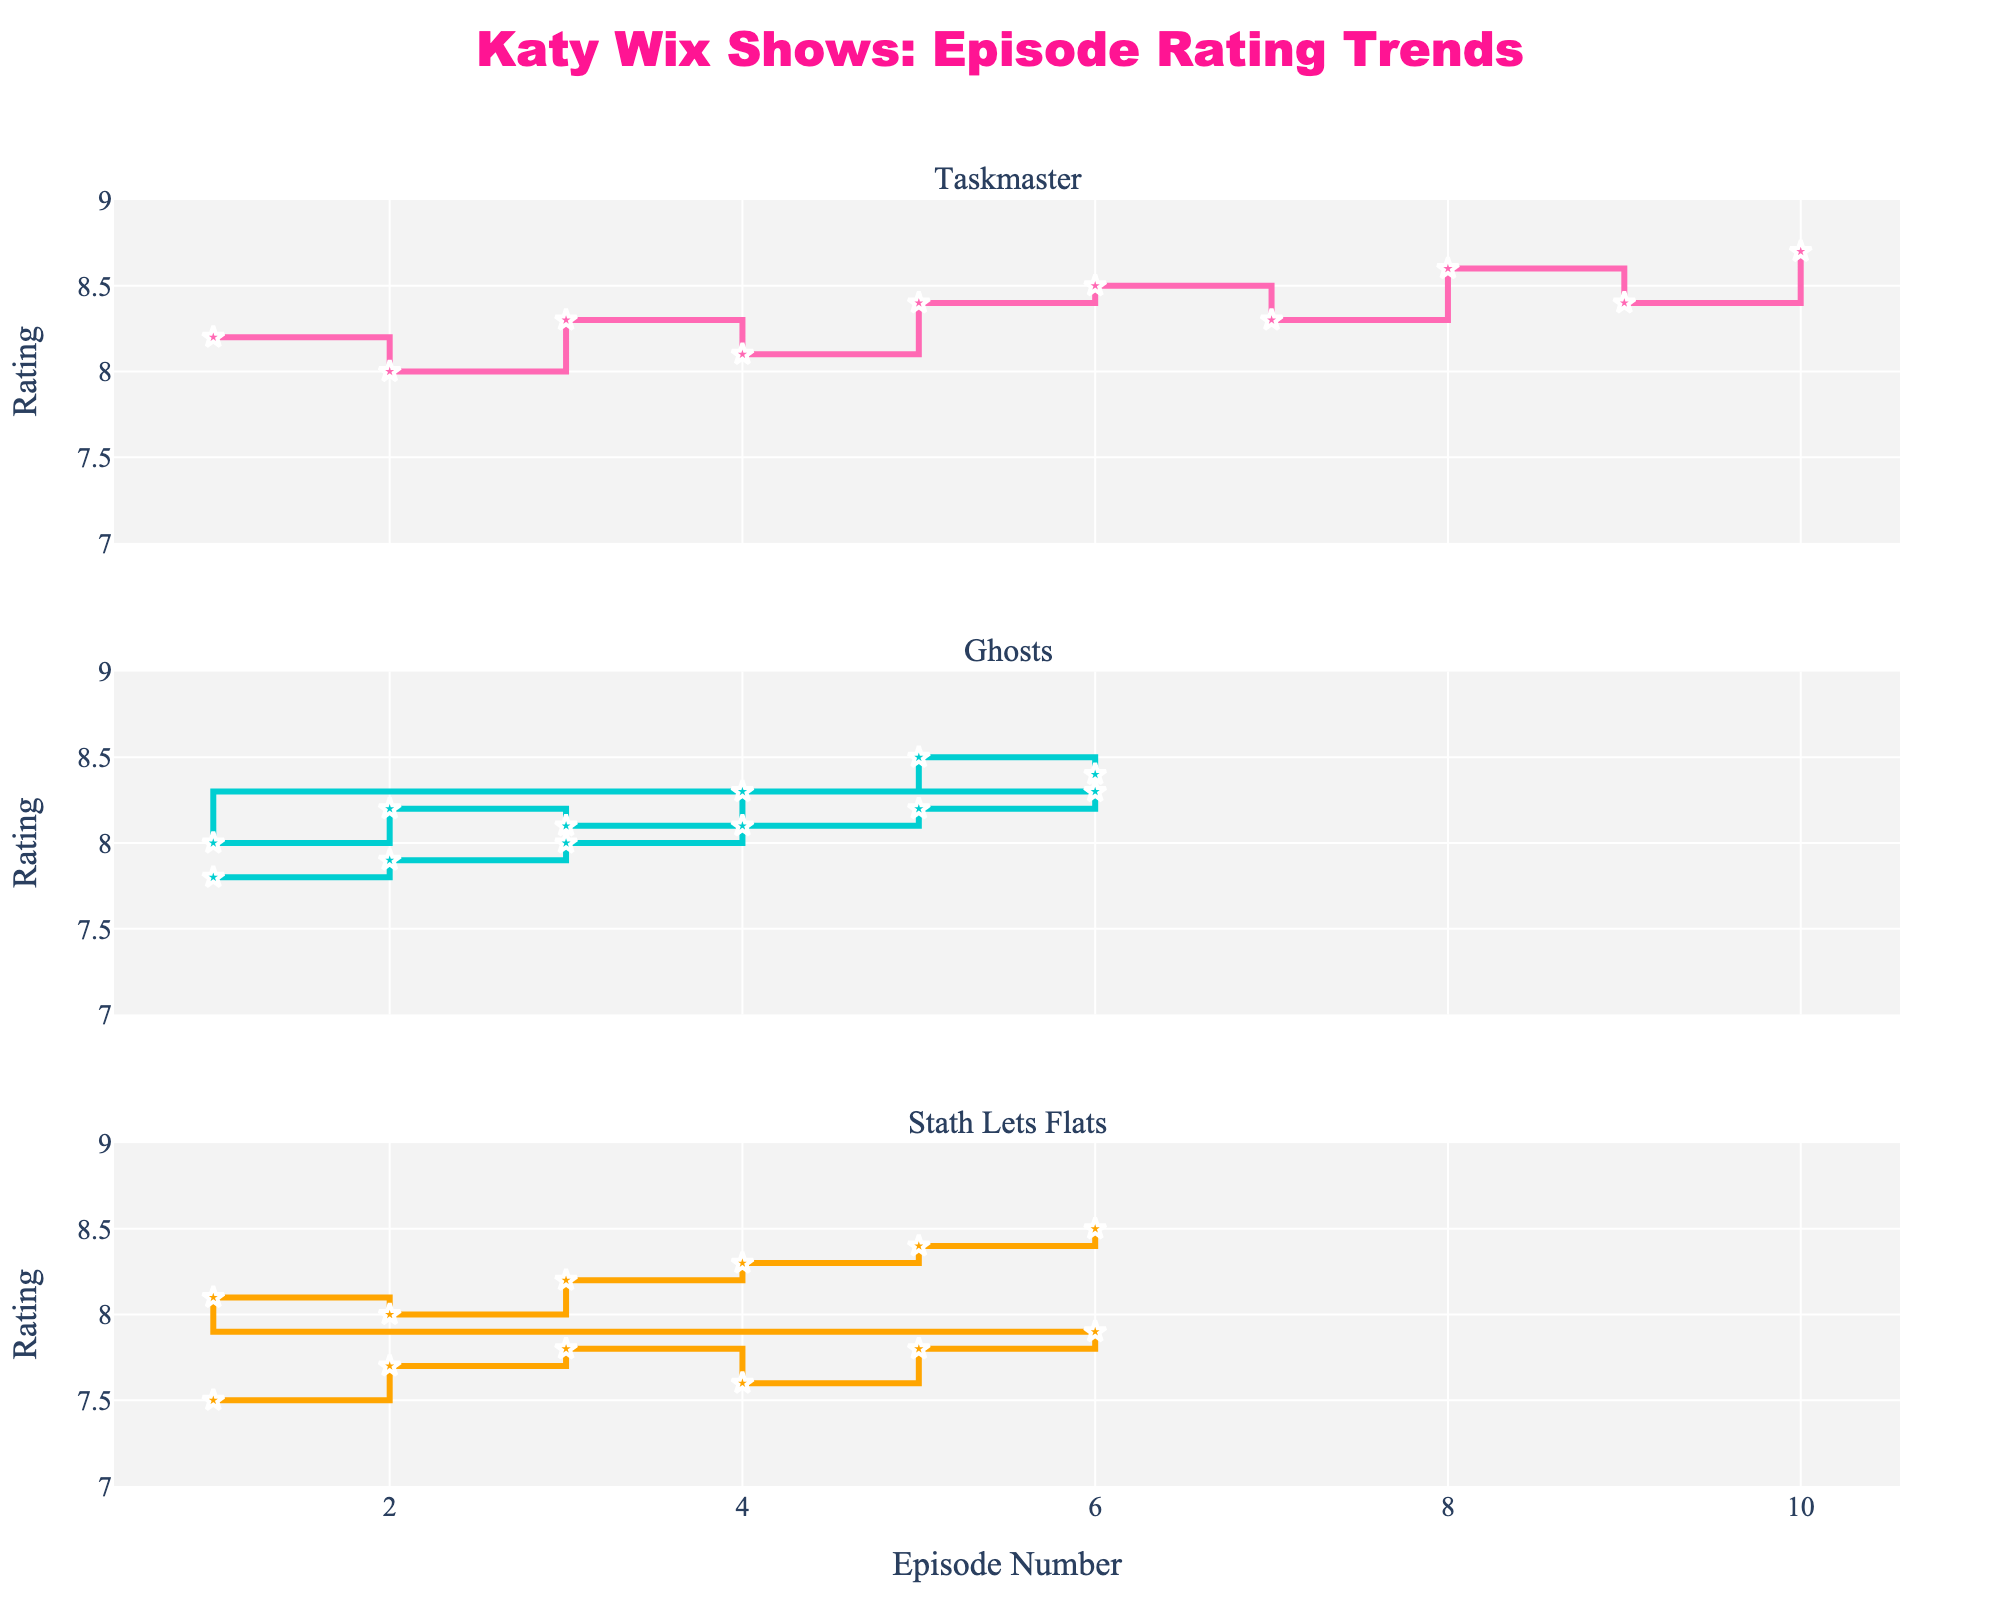What's the title of the plot? The title is located at the top and reads "Katy Wix Shows: Episode Rating Trends".
Answer: Katy Wix Shows: Episode Rating Trends Which show has the highest overall rating in any episode? By looking at the peak of each line, Taskmaster has the highest rating with an episode rating of 8.7.
Answer: Taskmaster How do the ratings for "Ghosts" change between the last episode of Season 1 and the first episode of Season 2? The last episode of Season 1 has a rating of 8.3 while the first episode of Season 2 has a rating of 8.0, showing a drop of 0.3.
Answer: 0.3 drop What is the overall trend in ratings for "Stath Lets Flats" from Season 1 to Season 2? By observing the lines, the ratings generally increase from Season 1 to Season 2 in "Stath Lets Flats".
Answer: Increase Did any episode of "Ghosts" in Season 2 receive a lower rating than any episodes in Season 1? By examining the ratings, no episode in Season 2 of "Ghosts" received a rating lower than the episodes in Season 1.
Answer: No Which show has the most episodes that are rated above 8.3? By counting the episodes above 8.3 for each show, Taskmaster has the most episodes rated above 8.3.
Answer: Taskmaster What’s the color of the line representing "Stath Lets Flats"? The line for "Stath Lets Flats" is orange.
Answer: Orange What's the average rating trend for "Taskmaster" in Season 6? Taskmaster starts at 8.2, increases to 8.7 by the final episode with several fluctuations throughout the season.
Answer: Increasing with fluctuations How does the rating of the last episode of "Stath Lets Flats" Season 1 compare to the rating of the last episode of "Ghosts" Season 1? The last episode of "Stath Lets Flats" Season 1 is rated 7.9, whereas the last episode of "Ghosts" Season 1 is rated 8.3. "Ghosts" has a higher rating.
Answer: Ghosts higher at 8.3 